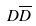<formula> <loc_0><loc_0><loc_500><loc_500>D \overline { D }</formula> 